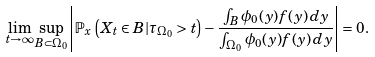<formula> <loc_0><loc_0><loc_500><loc_500>\lim _ { t \rightarrow \infty } \sup _ { B \subset { \Omega _ { 0 } } } \left | \mathbb { P } _ { x } \left ( X _ { t } \in B | \tau _ { \Omega _ { 0 } } > t \right ) - \frac { \int _ { B } \phi _ { 0 } ( y ) f ( y ) \, d y } { \int _ { \Omega _ { 0 } } \phi _ { 0 } ( y ) f ( y ) \, d y } \right | = 0 .</formula> 